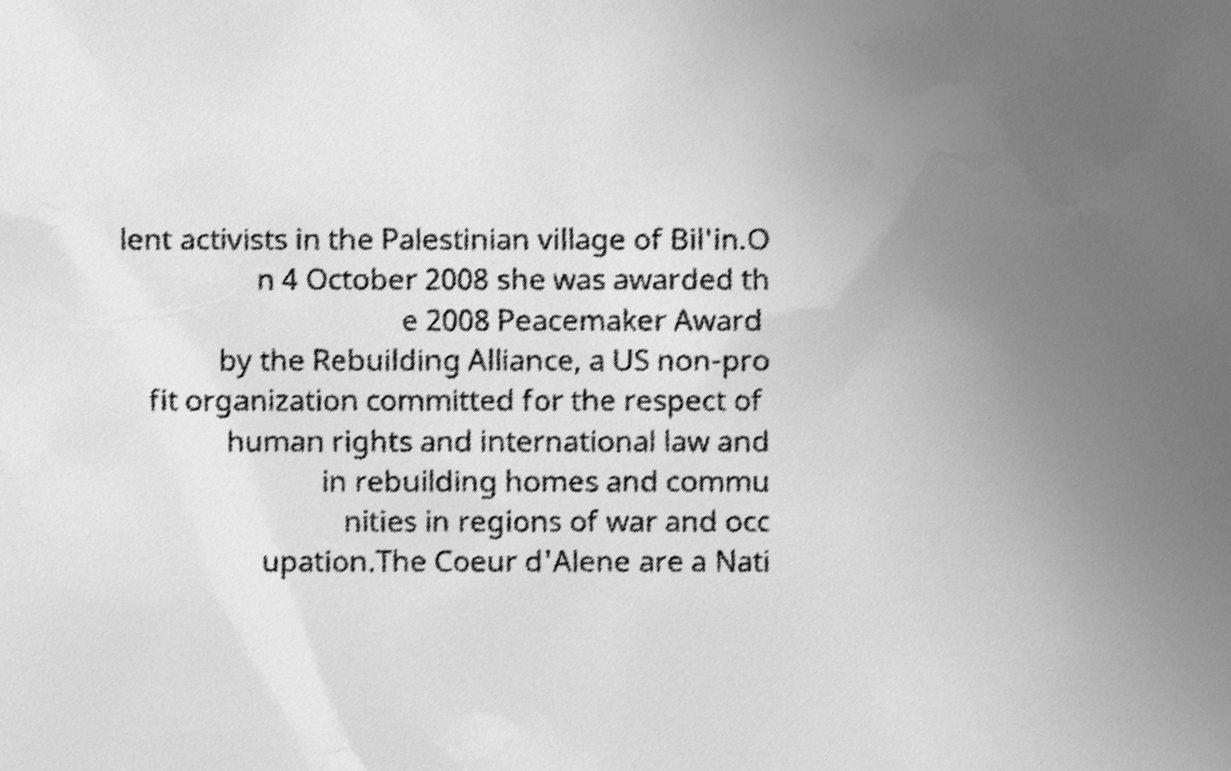I need the written content from this picture converted into text. Can you do that? lent activists in the Palestinian village of Bil'in.O n 4 October 2008 she was awarded th e 2008 Peacemaker Award by the Rebuilding Alliance, a US non-pro fit organization committed for the respect of human rights and international law and in rebuilding homes and commu nities in regions of war and occ upation.The Coeur d'Alene are a Nati 